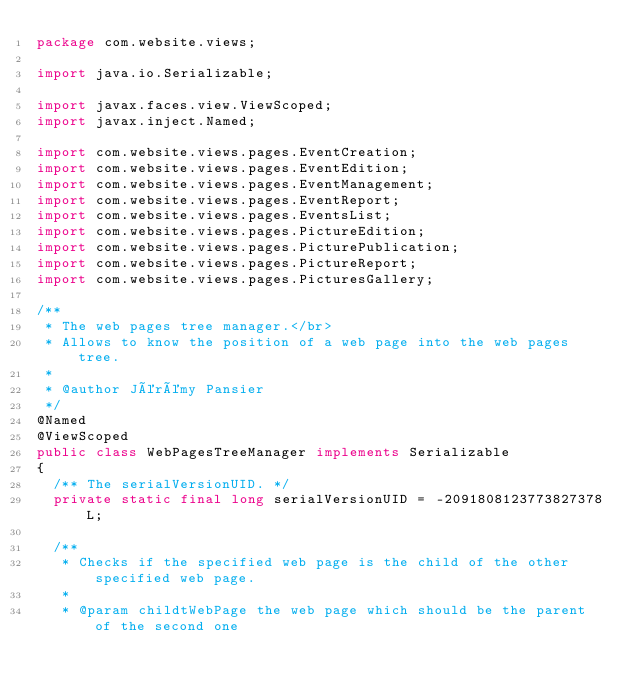Convert code to text. <code><loc_0><loc_0><loc_500><loc_500><_Java_>package com.website.views;

import java.io.Serializable;

import javax.faces.view.ViewScoped;
import javax.inject.Named;

import com.website.views.pages.EventCreation;
import com.website.views.pages.EventEdition;
import com.website.views.pages.EventManagement;
import com.website.views.pages.EventReport;
import com.website.views.pages.EventsList;
import com.website.views.pages.PictureEdition;
import com.website.views.pages.PicturePublication;
import com.website.views.pages.PictureReport;
import com.website.views.pages.PicturesGallery;

/**
 * The web pages tree manager.</br>
 * Allows to know the position of a web page into the web pages tree.
 *
 * @author Jérémy Pansier
 */
@Named
@ViewScoped
public class WebPagesTreeManager implements Serializable
{
	/** The serialVersionUID. */
	private static final long serialVersionUID = -2091808123773827378L;

	/**
	 * Checks if the specified web page is the child of the other specified web page.
	 *
	 * @param childtWebPage the web page which should be the parent of the second one</code> 